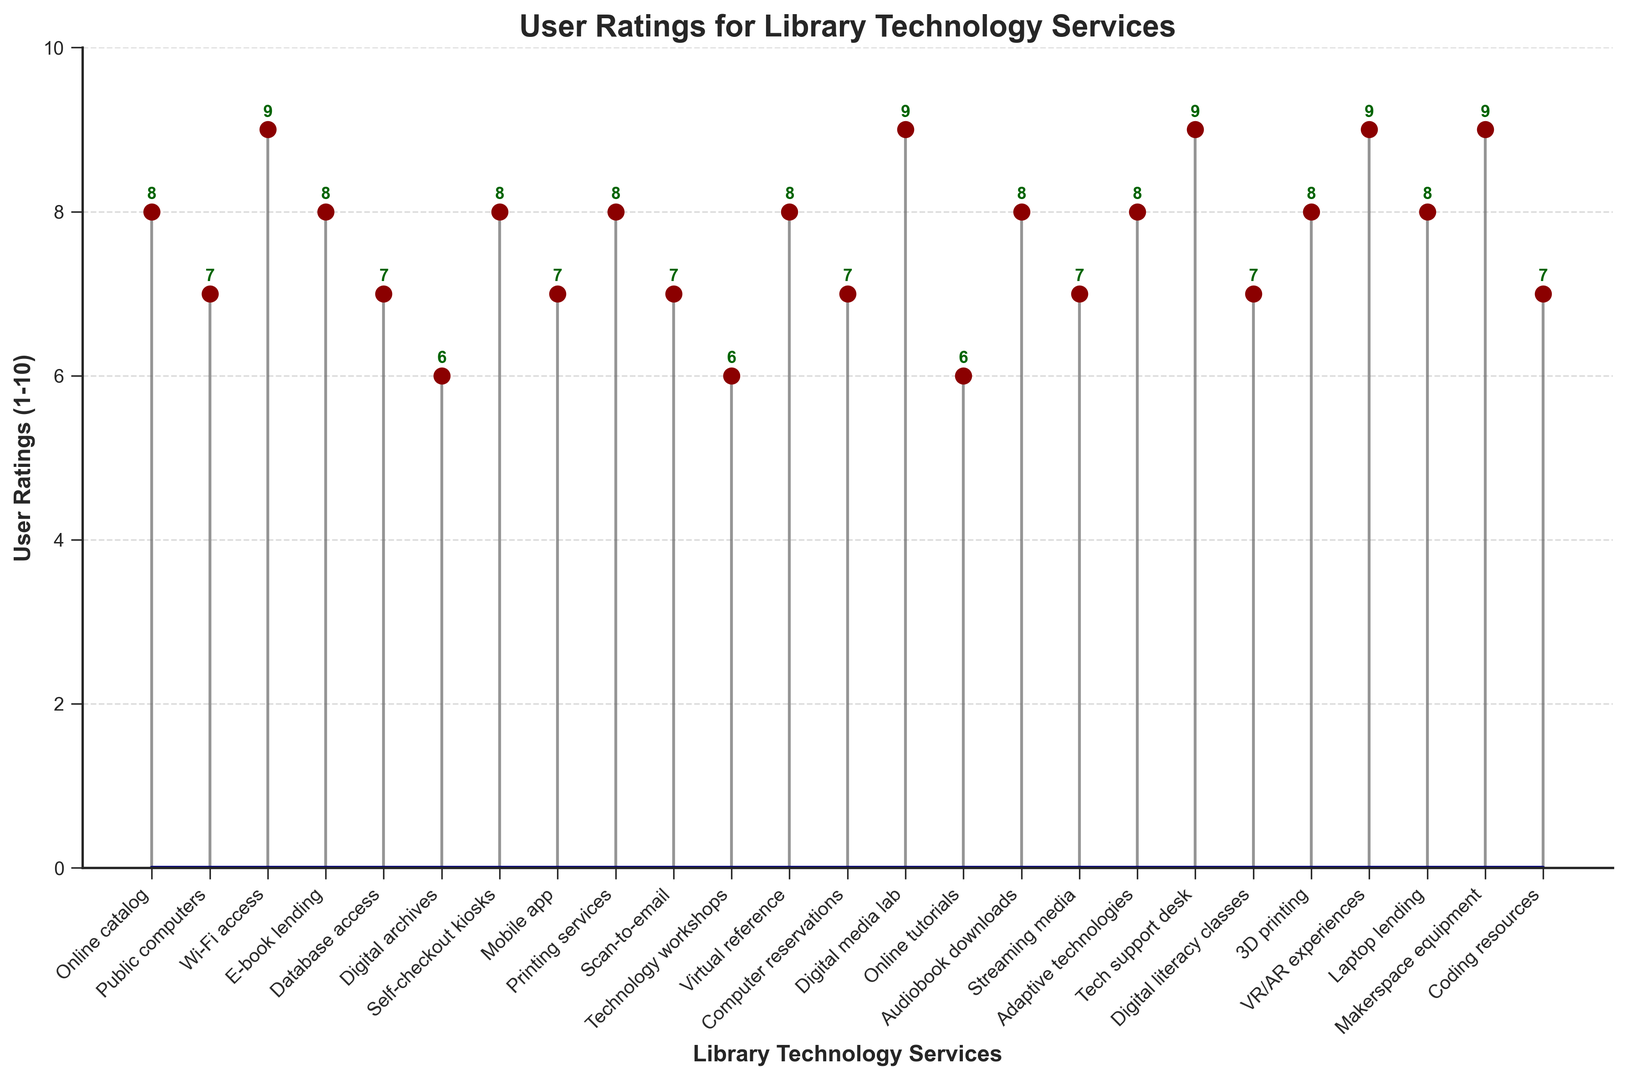What's the highest user rating among all services? Look at the plot and find the highest stem. The highest stem corresponds to a rating of 9 which is received by multiple services.
Answer: 9 Which service has the lowest user rating? Identify the shortest stem in the plot. The shortest stems correspond to a rating of 6 for 'Digital archives', 'Technology workshops', and 'Online tutorials'.
Answer: Digital archives, Technology workshops, Online tutorials What is the average user rating for 'E-book lending', 'Scanning to email', and 'Tech support desk'? Sum the ratings for these services: 'E-book lending' (8), 'Scan-to-email' (7), and 'Tech support desk' (9). Then divide by the number of services. (8+7+9)/3 = 8.
Answer: 8 How many services have a user rating of 8? Count the number of stems that correspond to a rating of 8.
Answer: 9 Which service has a higher rating: 'Mobile app' or 'Public computers'? Compare the stem heights for 'Mobile app' and 'Public computers'. 'Mobile app' (7), 'Public computers' (7). Both have the same rating.
Answer: Equal What's the total number of services with user ratings of 7 or higher? Count the stems that have heights of 7, 8, 9, or 10.
Answer: 23 Is the rating for 'E-book lending' higher or lower than 'Wi-Fi access'? Compare the stem heights for 'E-book lending' (8) and 'Wi-Fi access' (9). 'E-book lending' has a lower rating.
Answer: Lower What is the combined user rating for '3D printing' and 'VR/AR experiences'? Add the ratings for '3D printing' (8) and 'VR/AR experiences' (9). 8+9=17.
Answer: 17 How does the user rating for 'Audiobook downloads' compare to the average rating of all services? Calculate the average rating of all services. Sum the ratings and divide by the number of services (196/26 = 7.54). 'Audiobook downloads' has a rating of 8, which is higher than the average. (Sum of ratings = 196, Number of services = 26).
Answer: Higher Among 'Self-checkout kiosks', 'Computer reservations', and 'Coding resources', which has the highest rating? Compare the individual ratings: 'Self-checkout kiosks' (8), 'Computer reservations' (7), 'Coding resources' (7). 'Self-checkout kiosks' has the highest rating.
Answer: Self-checkout kiosks 